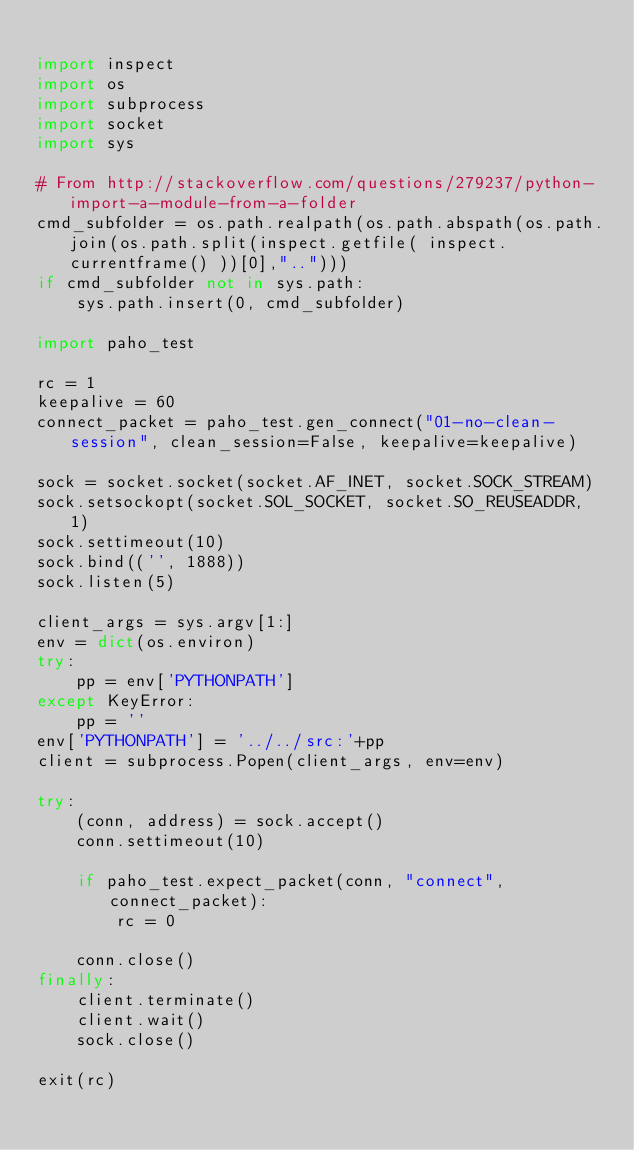Convert code to text. <code><loc_0><loc_0><loc_500><loc_500><_Python_>
import inspect
import os
import subprocess
import socket
import sys

# From http://stackoverflow.com/questions/279237/python-import-a-module-from-a-folder
cmd_subfolder = os.path.realpath(os.path.abspath(os.path.join(os.path.split(inspect.getfile( inspect.currentframe() ))[0],"..")))
if cmd_subfolder not in sys.path:
    sys.path.insert(0, cmd_subfolder)

import paho_test

rc = 1
keepalive = 60
connect_packet = paho_test.gen_connect("01-no-clean-session", clean_session=False, keepalive=keepalive)

sock = socket.socket(socket.AF_INET, socket.SOCK_STREAM)
sock.setsockopt(socket.SOL_SOCKET, socket.SO_REUSEADDR, 1)
sock.settimeout(10)
sock.bind(('', 1888))
sock.listen(5)

client_args = sys.argv[1:]
env = dict(os.environ)
try:
    pp = env['PYTHONPATH']
except KeyError:
    pp = ''
env['PYTHONPATH'] = '../../src:'+pp
client = subprocess.Popen(client_args, env=env)

try:
    (conn, address) = sock.accept()
    conn.settimeout(10)

    if paho_test.expect_packet(conn, "connect", connect_packet):
        rc = 0

    conn.close()
finally:
    client.terminate()
    client.wait()
    sock.close()

exit(rc)

</code> 